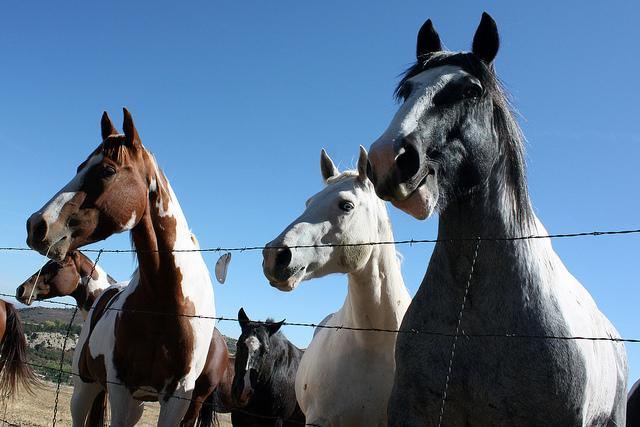What kind of fencing is used around these horses to keep them confined? barbed wire 